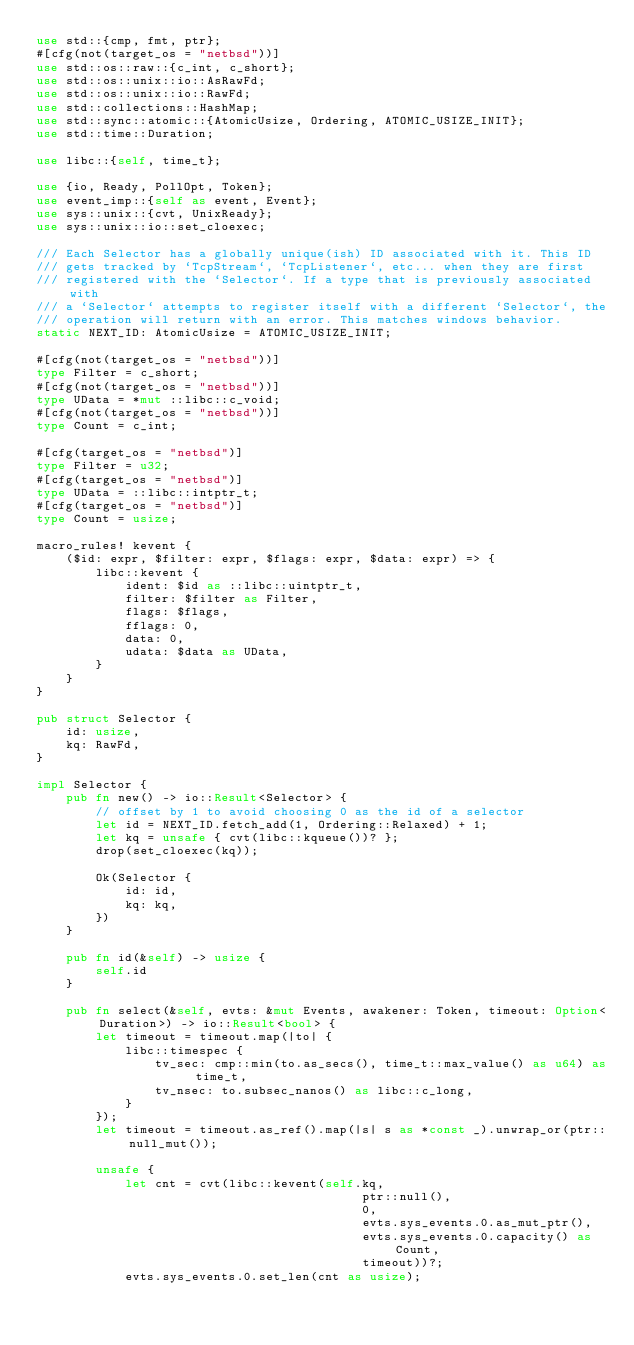<code> <loc_0><loc_0><loc_500><loc_500><_Rust_>use std::{cmp, fmt, ptr};
#[cfg(not(target_os = "netbsd"))]
use std::os::raw::{c_int, c_short};
use std::os::unix::io::AsRawFd;
use std::os::unix::io::RawFd;
use std::collections::HashMap;
use std::sync::atomic::{AtomicUsize, Ordering, ATOMIC_USIZE_INIT};
use std::time::Duration;

use libc::{self, time_t};

use {io, Ready, PollOpt, Token};
use event_imp::{self as event, Event};
use sys::unix::{cvt, UnixReady};
use sys::unix::io::set_cloexec;

/// Each Selector has a globally unique(ish) ID associated with it. This ID
/// gets tracked by `TcpStream`, `TcpListener`, etc... when they are first
/// registered with the `Selector`. If a type that is previously associated with
/// a `Selector` attempts to register itself with a different `Selector`, the
/// operation will return with an error. This matches windows behavior.
static NEXT_ID: AtomicUsize = ATOMIC_USIZE_INIT;

#[cfg(not(target_os = "netbsd"))]
type Filter = c_short;
#[cfg(not(target_os = "netbsd"))]
type UData = *mut ::libc::c_void;
#[cfg(not(target_os = "netbsd"))]
type Count = c_int;

#[cfg(target_os = "netbsd")]
type Filter = u32;
#[cfg(target_os = "netbsd")]
type UData = ::libc::intptr_t;
#[cfg(target_os = "netbsd")]
type Count = usize;

macro_rules! kevent {
    ($id: expr, $filter: expr, $flags: expr, $data: expr) => {
        libc::kevent {
            ident: $id as ::libc::uintptr_t,
            filter: $filter as Filter,
            flags: $flags,
            fflags: 0,
            data: 0,
            udata: $data as UData,
        }
    }
}

pub struct Selector {
    id: usize,
    kq: RawFd,
}

impl Selector {
    pub fn new() -> io::Result<Selector> {
        // offset by 1 to avoid choosing 0 as the id of a selector
        let id = NEXT_ID.fetch_add(1, Ordering::Relaxed) + 1;
        let kq = unsafe { cvt(libc::kqueue())? };
        drop(set_cloexec(kq));

        Ok(Selector {
            id: id,
            kq: kq,
        })
    }

    pub fn id(&self) -> usize {
        self.id
    }

    pub fn select(&self, evts: &mut Events, awakener: Token, timeout: Option<Duration>) -> io::Result<bool> {
        let timeout = timeout.map(|to| {
            libc::timespec {
                tv_sec: cmp::min(to.as_secs(), time_t::max_value() as u64) as time_t,
                tv_nsec: to.subsec_nanos() as libc::c_long,
            }
        });
        let timeout = timeout.as_ref().map(|s| s as *const _).unwrap_or(ptr::null_mut());

        unsafe {
            let cnt = cvt(libc::kevent(self.kq,
                                            ptr::null(),
                                            0,
                                            evts.sys_events.0.as_mut_ptr(),
                                            evts.sys_events.0.capacity() as Count,
                                            timeout))?;
            evts.sys_events.0.set_len(cnt as usize);</code> 